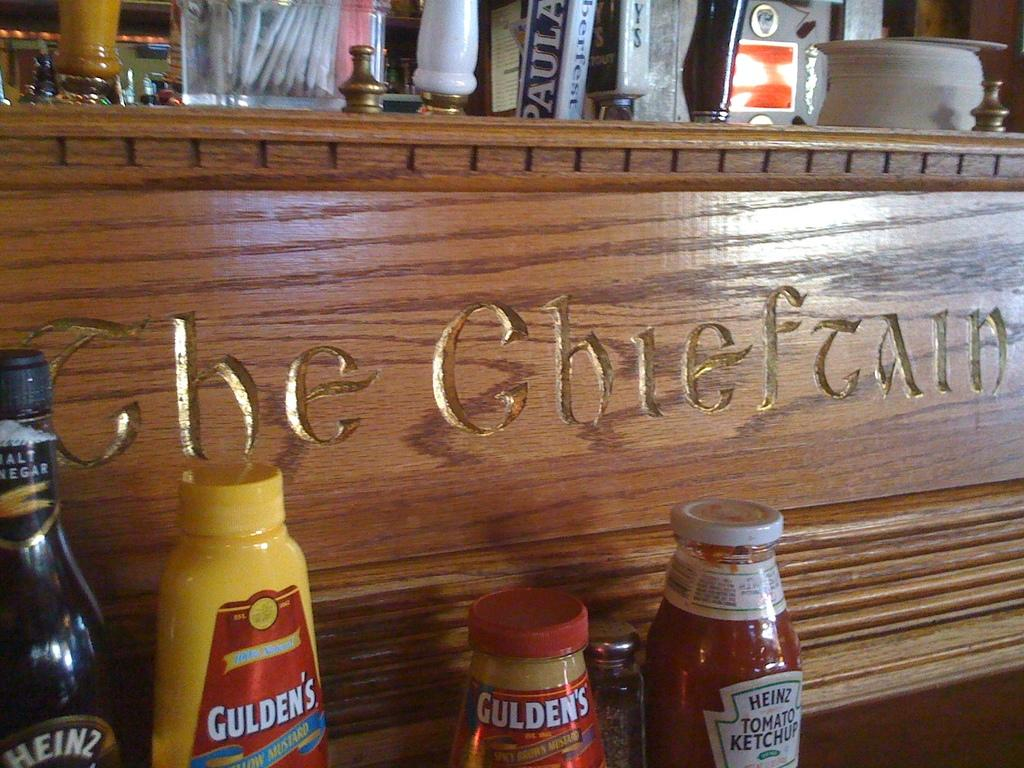Provide a one-sentence caption for the provided image. A variety of condiments like heinz branded tomato ketchup are arranged next to a wooden panel. 